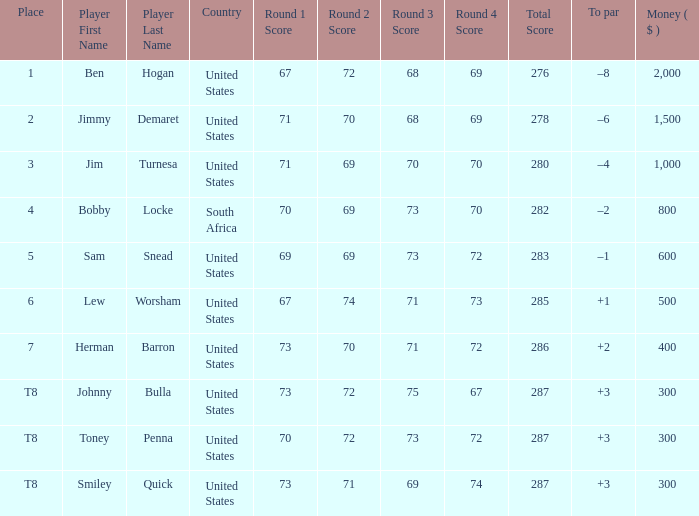What is the Place of the Player with a To par of –1? 5.0. 